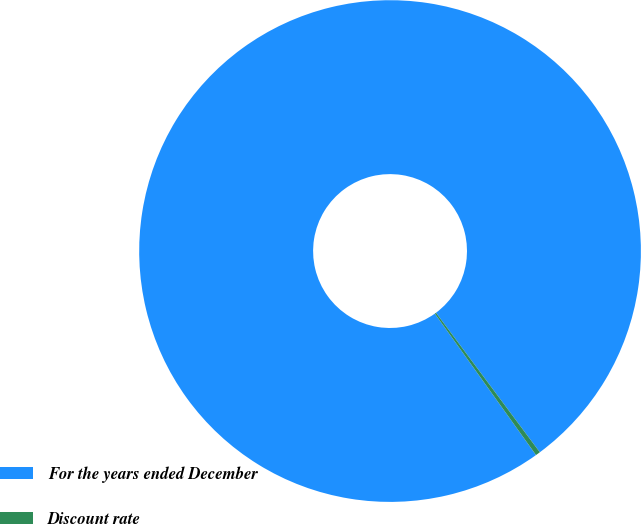Convert chart. <chart><loc_0><loc_0><loc_500><loc_500><pie_chart><fcel>For the years ended December<fcel>Discount rate<nl><fcel>99.7%<fcel>0.3%<nl></chart> 